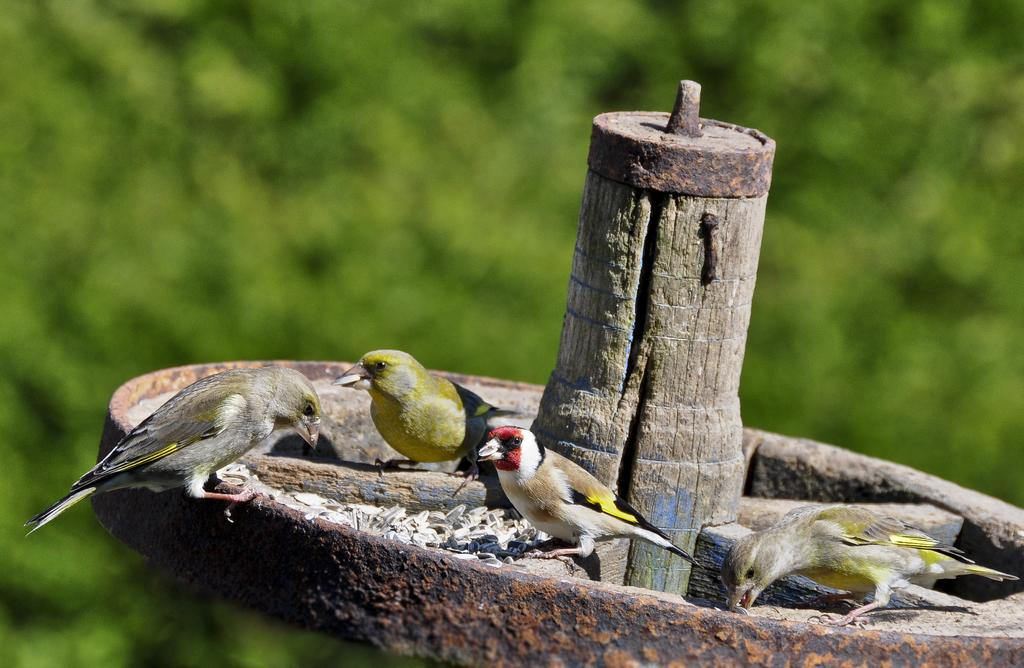What are the birds perched on in the image? The birds are on a stand with metal rings in the image. What can be seen in the background of the image? There is a group of trees in the background of the image. What type of rifle is being used to shoot the birds in the image? There is no rifle or shooting activity depicted in the image; the birds are simply perched on a stand with metal rings. 